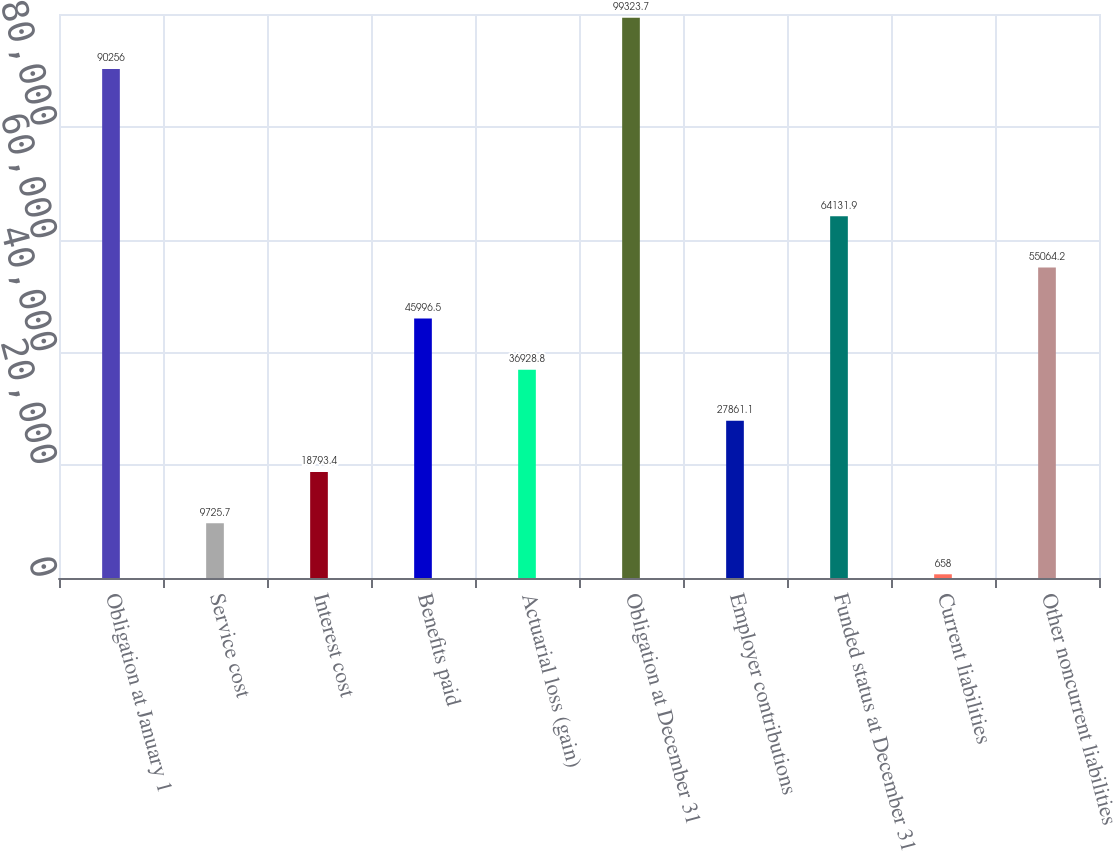Convert chart. <chart><loc_0><loc_0><loc_500><loc_500><bar_chart><fcel>Obligation at January 1<fcel>Service cost<fcel>Interest cost<fcel>Benefits paid<fcel>Actuarial loss (gain)<fcel>Obligation at December 31<fcel>Employer contributions<fcel>Funded status at December 31<fcel>Current liabilities<fcel>Other noncurrent liabilities<nl><fcel>90256<fcel>9725.7<fcel>18793.4<fcel>45996.5<fcel>36928.8<fcel>99323.7<fcel>27861.1<fcel>64131.9<fcel>658<fcel>55064.2<nl></chart> 